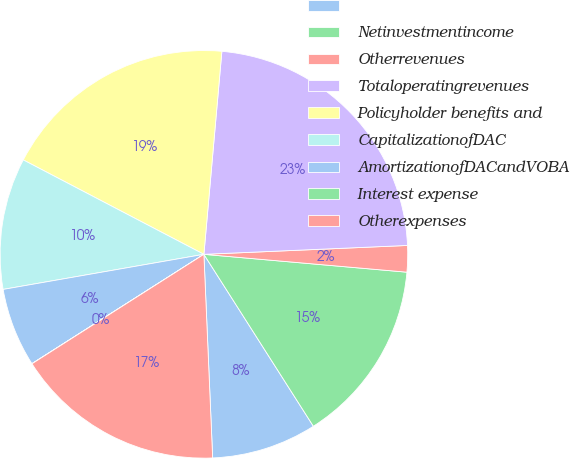Convert chart. <chart><loc_0><loc_0><loc_500><loc_500><pie_chart><ecel><fcel>Netinvestmentincome<fcel>Otherrevenues<fcel>Totaloperatingrevenues<fcel>Policyholder benefits and<fcel>CapitalizationofDAC<fcel>AmortizationofDACandVOBA<fcel>Interest expense<fcel>Otherexpenses<nl><fcel>8.34%<fcel>14.58%<fcel>2.09%<fcel>22.9%<fcel>18.74%<fcel>10.42%<fcel>6.26%<fcel>0.01%<fcel>16.66%<nl></chart> 